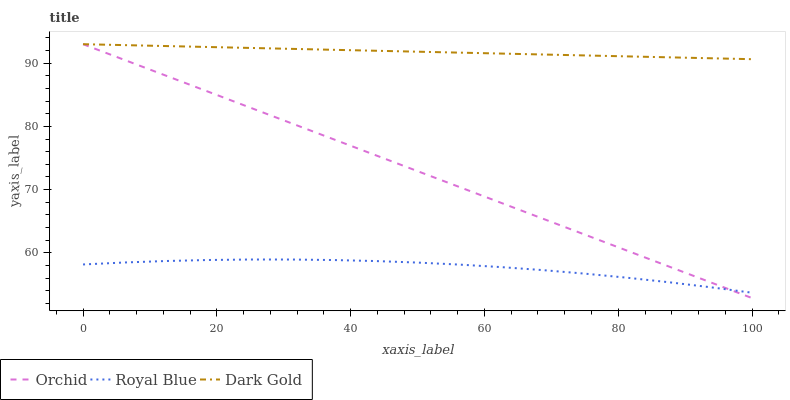Does Royal Blue have the minimum area under the curve?
Answer yes or no. Yes. Does Dark Gold have the maximum area under the curve?
Answer yes or no. Yes. Does Orchid have the minimum area under the curve?
Answer yes or no. No. Does Orchid have the maximum area under the curve?
Answer yes or no. No. Is Dark Gold the smoothest?
Answer yes or no. Yes. Is Royal Blue the roughest?
Answer yes or no. Yes. Is Orchid the smoothest?
Answer yes or no. No. Is Orchid the roughest?
Answer yes or no. No. Does Dark Gold have the lowest value?
Answer yes or no. No. Does Orchid have the highest value?
Answer yes or no. Yes. Is Royal Blue less than Dark Gold?
Answer yes or no. Yes. Is Dark Gold greater than Royal Blue?
Answer yes or no. Yes. Does Royal Blue intersect Orchid?
Answer yes or no. Yes. Is Royal Blue less than Orchid?
Answer yes or no. No. Is Royal Blue greater than Orchid?
Answer yes or no. No. Does Royal Blue intersect Dark Gold?
Answer yes or no. No. 